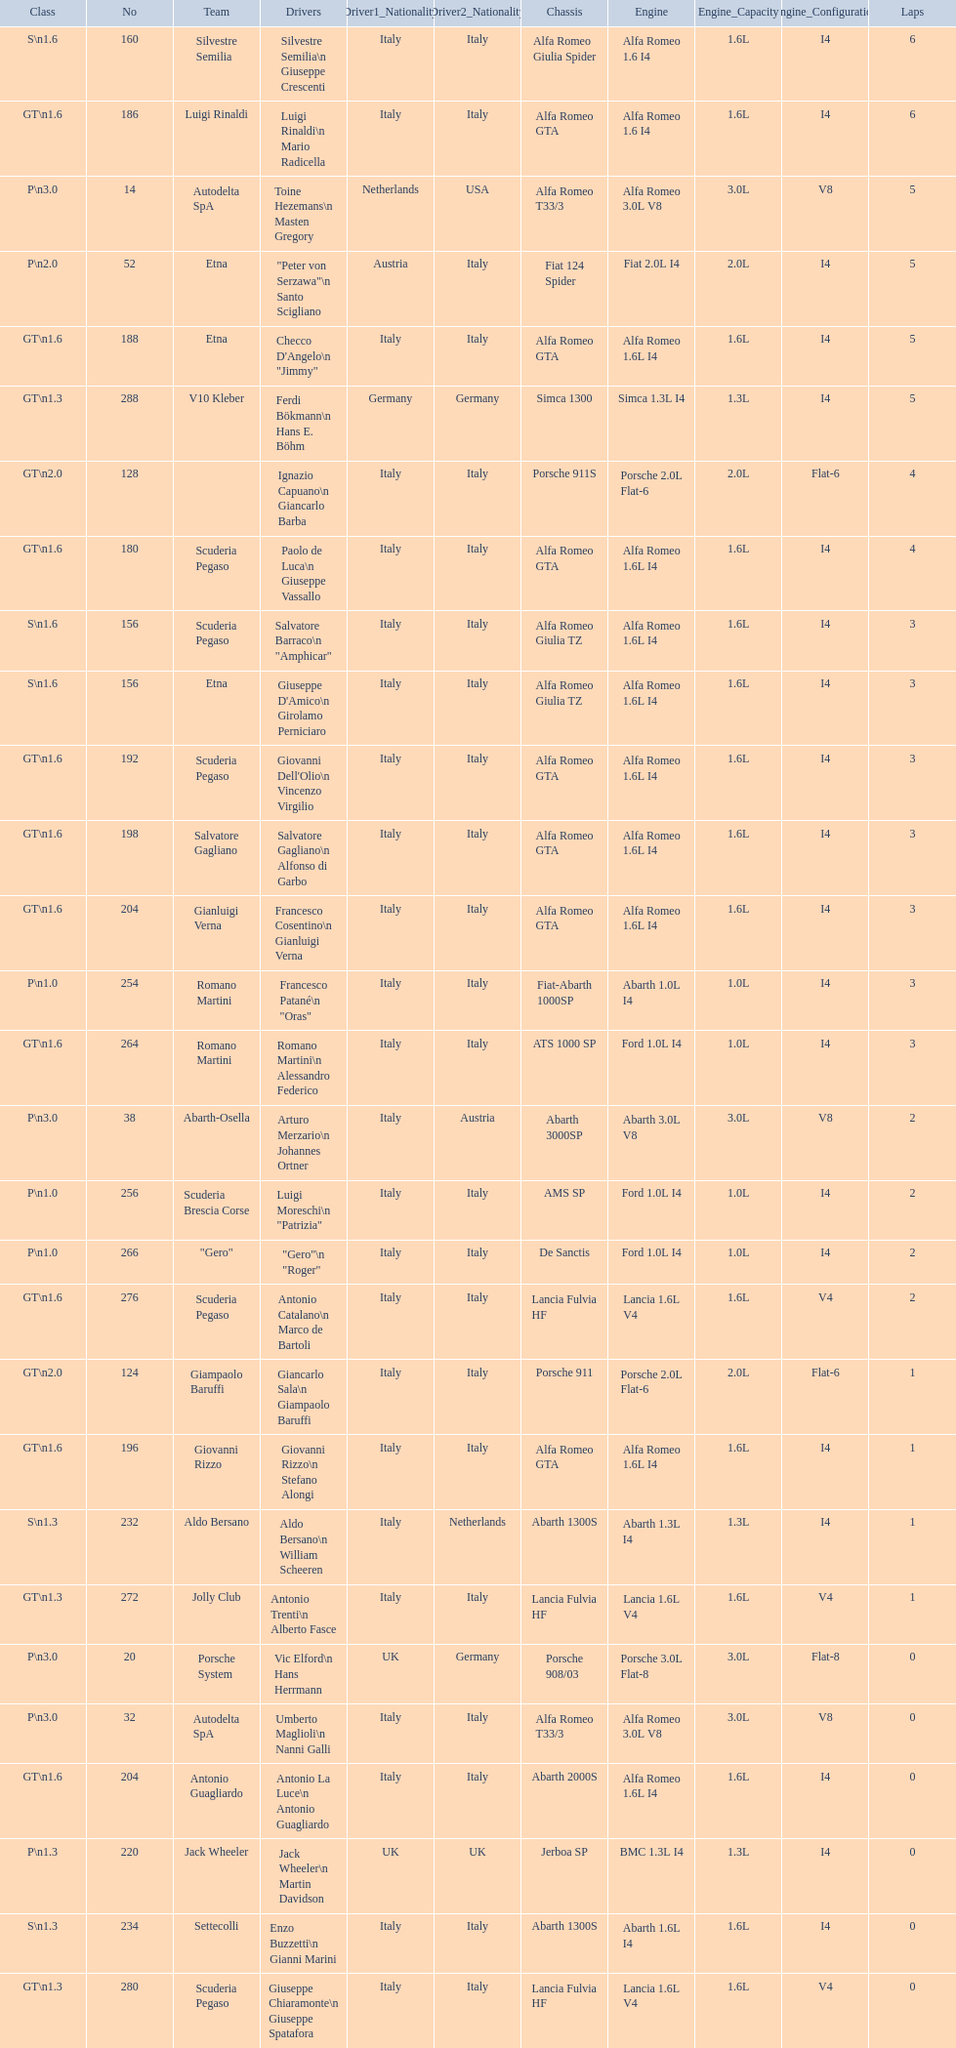What class is below s 1.6? GT 1.6. 